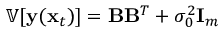<formula> <loc_0><loc_0><loc_500><loc_500>\mathbb { V } [ \mathbf y ( \mathbf x _ { t } ) ] = \mathbf B \mathbf B ^ { T } + \sigma _ { 0 } ^ { 2 } \mathbf I _ { m }</formula> 